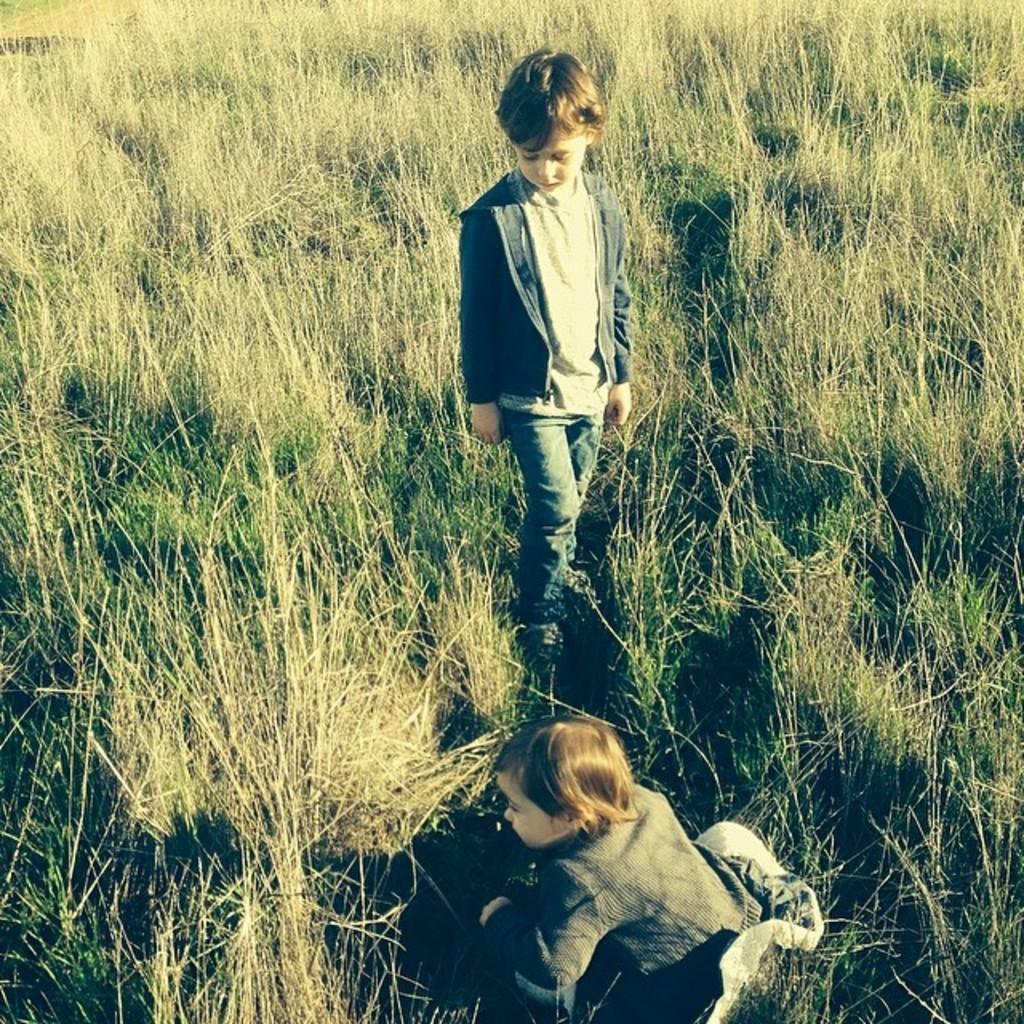In one or two sentences, can you explain what this image depicts? At the bottom of the picture, we see a girl is sitting. Beside her, we see a boy in the grey T-shirt is standing. In the background, we see the grass. 